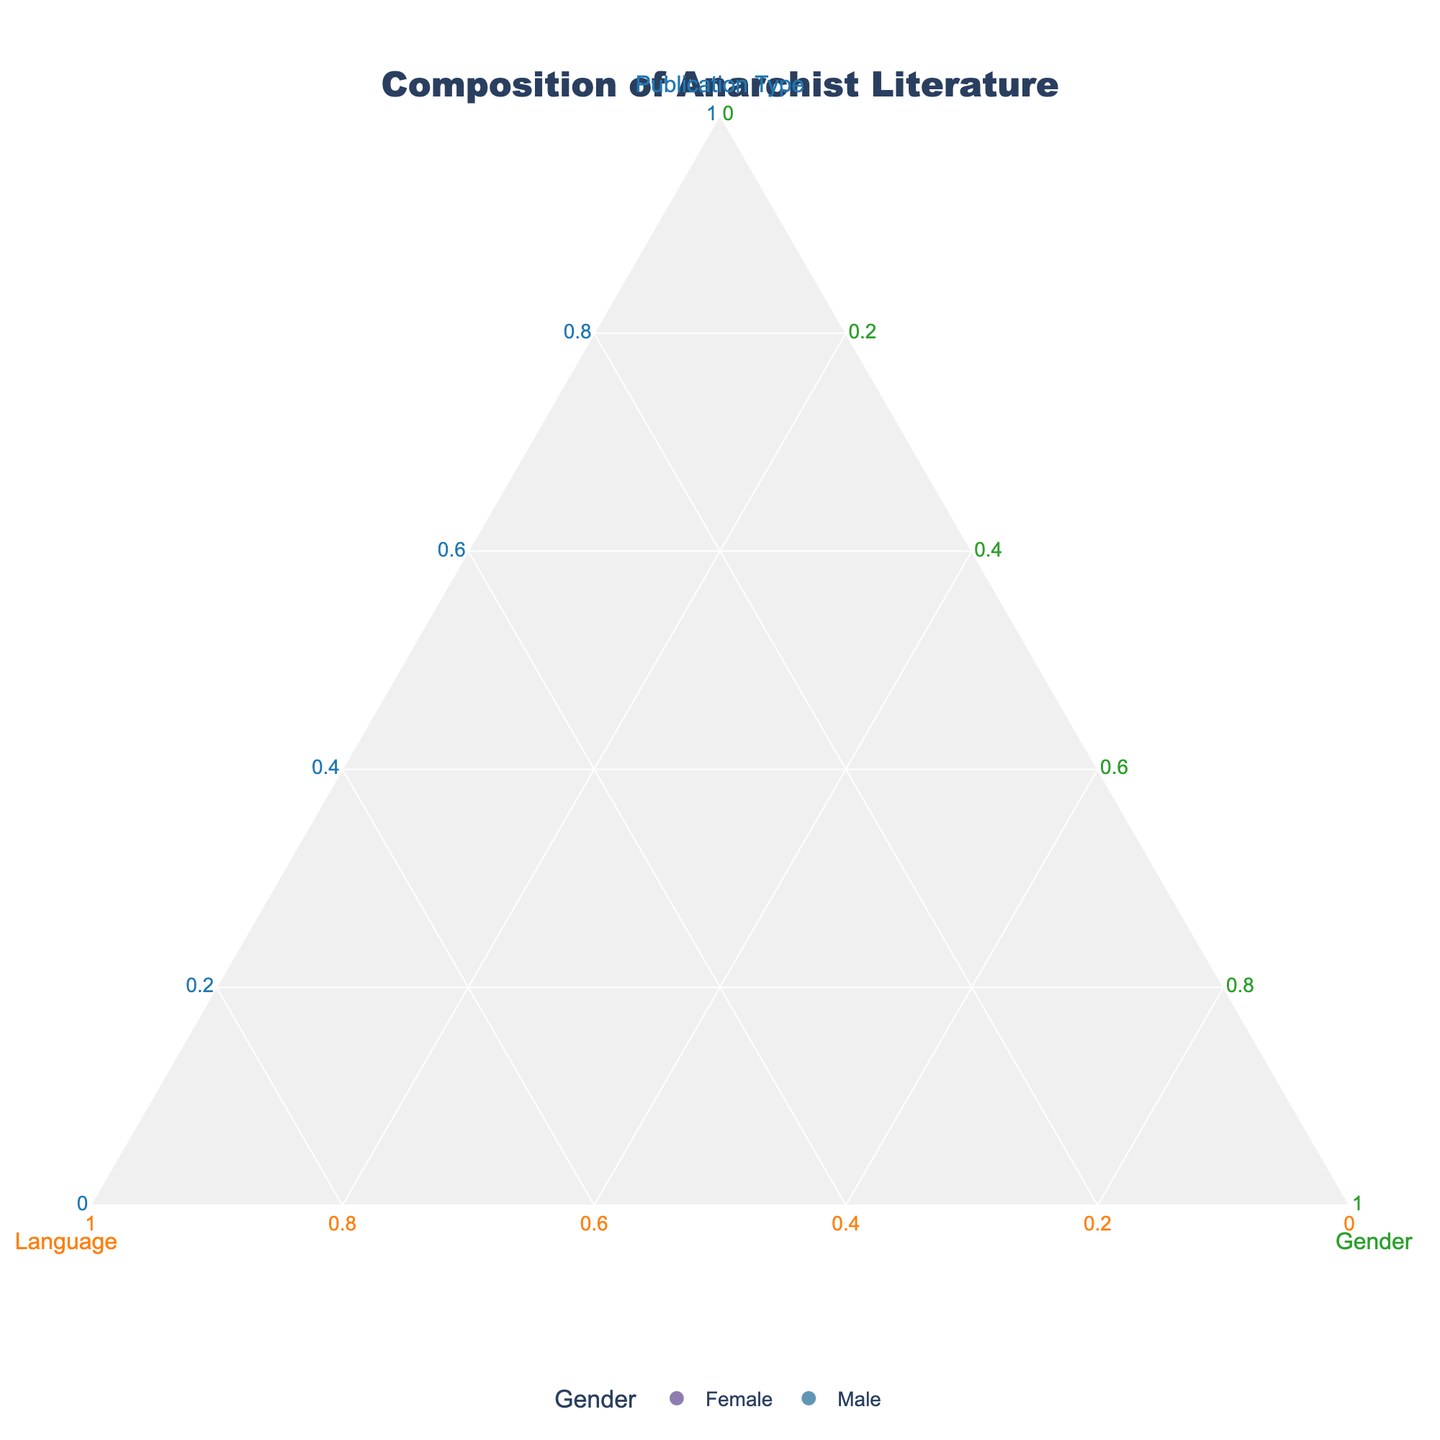How many colors are used to denote the different genders? The plot uses a custom color scale to represent different genders. From the data, we can see only two genders are represented: Female and Male. Therefore, two colors are used to denote the different genders shown in the legend.
Answer: Two What is the title of the figure? The title is displayed prominently at the top of the figure. Its description provides the general context for the visualization.
Answer: Composition of Anarchist Literature Which gender has the highest value for the Russian language in books? To answer this, we look at the Russian language entries and their corresponding values. We find that "Male, Russian, Books" has a value of 0.70, and "Female, Russian, Books" is not present. Thus, the highest value for Russian in books is for males.
Answer: Male For Portuguese pamphlets, what are the values for both genders? Looking at the entries for Portuguese language and pamphlets publication types, the values are "Female, Portuguese, Pamphlets, 0.35" and "Male, Portuguese, Pamphlets, 0.45".
Answer: Female: 0.35, Male: 0.45 Which publication type has the highest representation for the female gender in the given data? By comparing the values for different female publications across all languages, we identify that "Female, Spanish, Newspapers" has the highest value of 0.40.
Answer: Newspapers (Spanish) Compare the representation of male literature in Italian pamphlets and English newspapers. Which one is greater and by how much? For "Male, Italian, Pamphlets," the value is 0.60. For "Male, English, Newspapers," the value is 0.65. Therefore, English newspapers have a greater representation by \(0.65 - 0.60 = 0.05\).
Answer: English Newspapers by 0.05 What is the average value for the female entries in books? The values for female entries in books are from French (0.30) and English (0.20). Adding these gives \(0.30 + 0.20 = 0.50\), and the average is \(0.50 / 2 = 0.25\).
Answer: 0.25 What is the combined value of female and male representation in Spanish publications? The relevant values are "Female, Spanish, Newspapers, 0.40" and "Male, Spanish, Books, 0.55". Summing these gives \(0.40 + 0.55 = 0.95\).
Answer: 0.95 In the context of this plot, which gender and publication type combination has the smallest value, and what is it? Reviewing all values, we see that "Female, Russian, Pamphlets, 0.15" is the smallest value in the dataset.
Answer: Female, Russian, Pamphlets, 0.15 